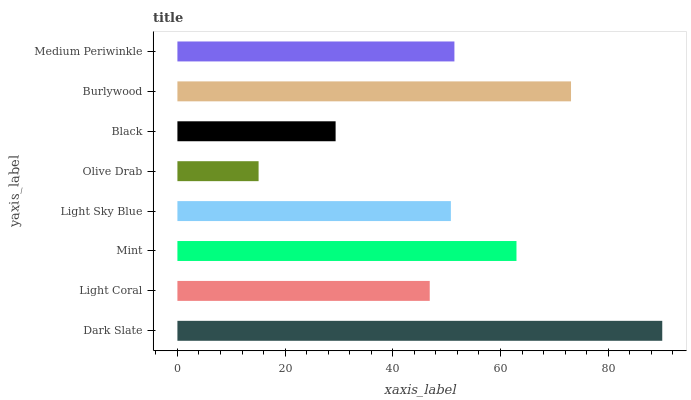Is Olive Drab the minimum?
Answer yes or no. Yes. Is Dark Slate the maximum?
Answer yes or no. Yes. Is Light Coral the minimum?
Answer yes or no. No. Is Light Coral the maximum?
Answer yes or no. No. Is Dark Slate greater than Light Coral?
Answer yes or no. Yes. Is Light Coral less than Dark Slate?
Answer yes or no. Yes. Is Light Coral greater than Dark Slate?
Answer yes or no. No. Is Dark Slate less than Light Coral?
Answer yes or no. No. Is Medium Periwinkle the high median?
Answer yes or no. Yes. Is Light Sky Blue the low median?
Answer yes or no. Yes. Is Burlywood the high median?
Answer yes or no. No. Is Dark Slate the low median?
Answer yes or no. No. 